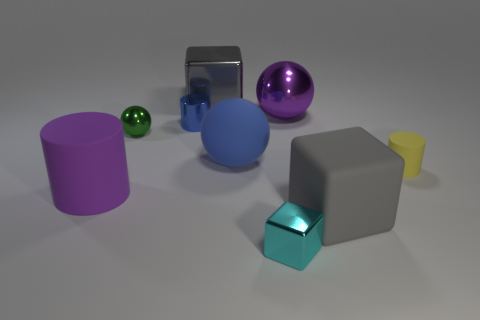Considering the arrangement of the objects, what could this image represent? This image could represent a study of shapes and materials, with each object demonstrating different geometric forms and surfaces that reflect or absorb light in various ways. It could also be an artistic representation of diversity or an educational image illustrating three-dimensional forms for learners. 